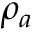Convert formula to latex. <formula><loc_0><loc_0><loc_500><loc_500>\rho _ { a }</formula> 